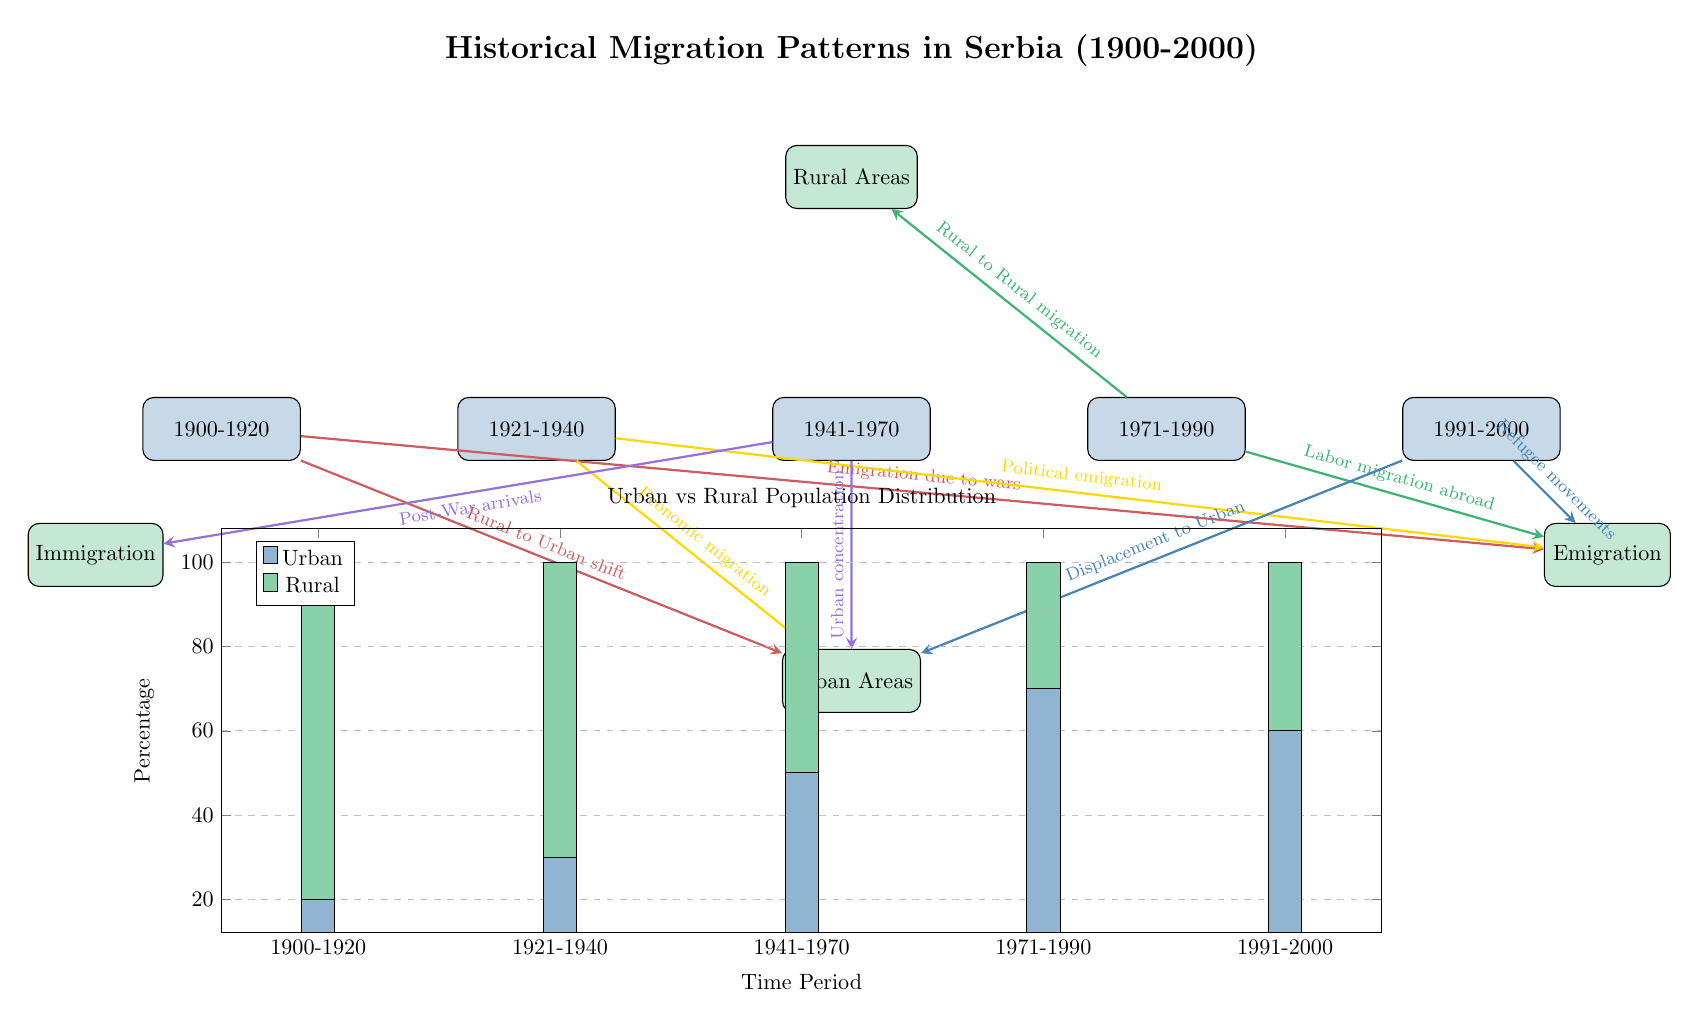What is the primary reason for rural to urban migration in the 1900-1920 period? The diagram indicates that the primary reason for rural to urban migration during the 1900-1920 period is labeled as "Rural to Urban shift," which is directly connected from the time period node (n1) to the urban areas node.
Answer: Rural to Urban shift Which time period shows the highest urban population percentage? By examining the heatmap section of the diagram, the urban population percentage peaks at 70% in the time period represented as 1971-1990 (node n4).
Answer: 70% How many times does labor migration abroad appear in the diagram? The diagram shows labor migration abroad as an arrow originating from the time period 1971-1990 (n4) and flowing towards the emigration node. This means that it appears once in the diagram.
Answer: 1 What flow direction indicates post-war arrivals? The direction concerning post-war arrivals is indicated by an arrow pointing from the time period 1941-1970 (node n3) towards the immigration node, showing the arrival of individuals following the war.
Answer: Immigration Which demographic group experienced a shift to urban areas in the 1991-2000 period? The diagram outlines that during the 1991-2000 period (node n5), there are two movements depicted: "Refugee movements" and "Displacement to Urban," both of which indicate demographic groups shifting to urban areas.
Answer: Refugees and Displaced people 